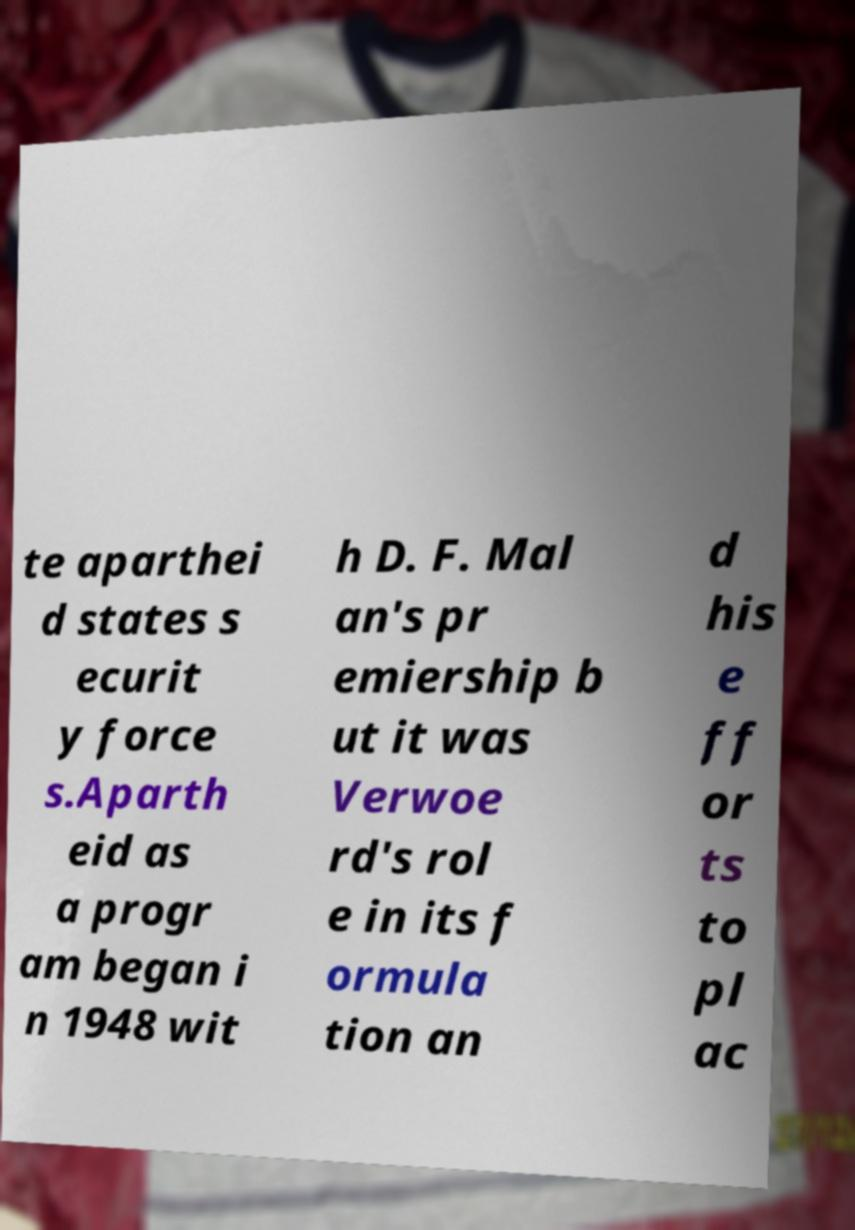Can you read and provide the text displayed in the image?This photo seems to have some interesting text. Can you extract and type it out for me? te aparthei d states s ecurit y force s.Aparth eid as a progr am began i n 1948 wit h D. F. Mal an's pr emiership b ut it was Verwoe rd's rol e in its f ormula tion an d his e ff or ts to pl ac 